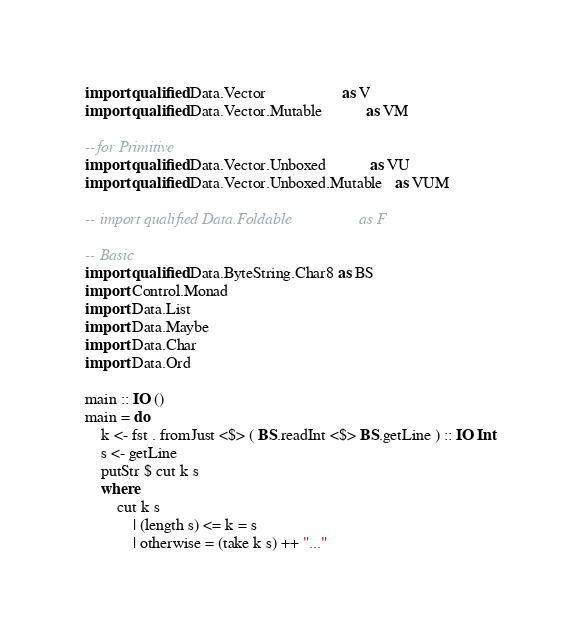Convert code to text. <code><loc_0><loc_0><loc_500><loc_500><_Haskell_>import qualified Data.Vector                   as V
import qualified Data.Vector.Mutable           as VM

--for Primitive
import qualified Data.Vector.Unboxed           as VU
import qualified Data.Vector.Unboxed.Mutable   as VUM

-- import qualified Data.Foldable                 as F

-- Basic
import qualified Data.ByteString.Char8 as BS
import Control.Monad
import Data.List
import Data.Maybe
import Data.Char
import Data.Ord

main :: IO ()
main = do
    k <- fst . fromJust <$> ( BS.readInt <$> BS.getLine ) :: IO Int
    s <- getLine
    putStr $ cut k s
    where
        cut k s 
            | (length s) <= k = s
            | otherwise = (take k s) ++ "..."</code> 